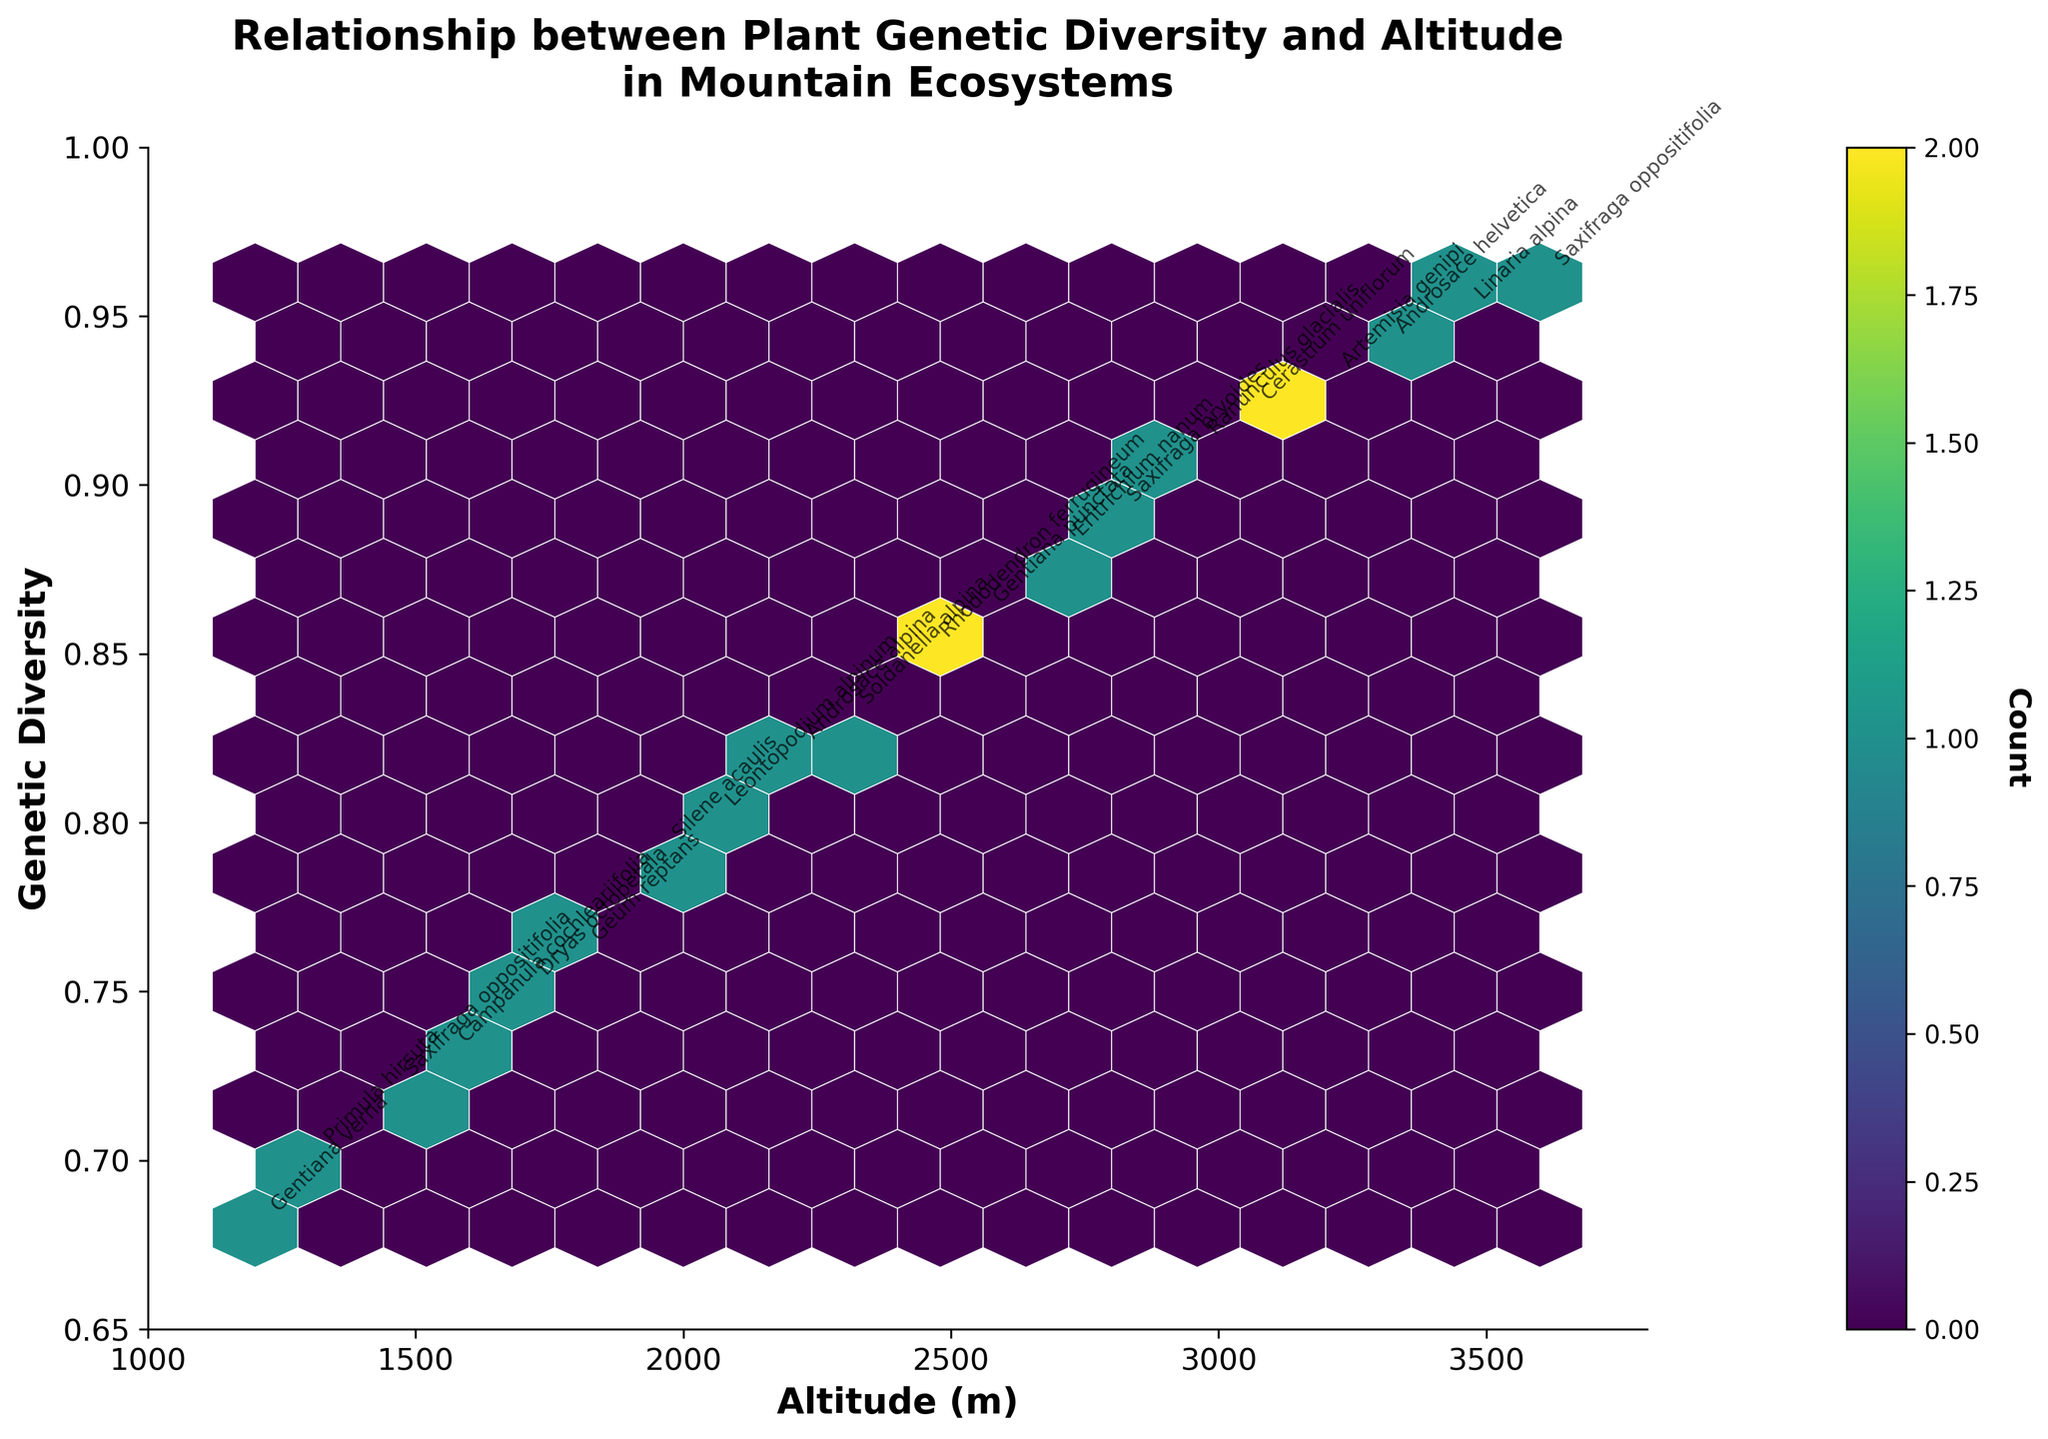What is the title of the plot? The title of the plot is shown at the top of the figure which reads "Relationship between Plant Genetic Diversity and Altitude in Mountain Ecosystems".
Answer: Relationship between Plant Genetic Diversity and Altitude in Mountain Ecosystems What are the x and y-axis labels? The x-axis label is "Altitude (m)", and the y-axis label is "Genetic Diversity". Both labels are clearly indicated along their respective axes.
Answer: Altitude (m), Genetic Diversity Which species has the highest altitude? By looking at the annotated data points, "Saxifraga oppositifolia" has the highest altitude of 3600 meters.
Answer: Saxifraga oppositifolia How many species have a genetic diversity greater than 0.90? From the annotations, the species "Ranunculus glacialis", "Artemisia genipi", "Linaria alpina", "Cerastium uniflorum", "Androsace helvetica", and "Saxifraga oppositifolia" have genetic diversity values greater than 0.90, so there are 6 species.
Answer: 6 What is the average genetic diversity of the species annotated with genome diversity details? The genetic diversity values for all species annotated are 0.68, 0.72, 0.75, 0.79, 0.82, 0.85, 0.88, 0.91, 0.93, 0.95, 0.70, 0.73, 0.76, 0.80, 0.83, 0.86, 0.89, 0.92, 0.94, 0.96. Adding these together gives 15.14 and dividing by 20 gives an average of 0.757.
Answer: 0.757 Which species has the lowest genetic diversity, and what is its altitude? The species annotated with the lowest genetic diversity is "Gentiana verna" with a genetic diversity of 0.68 at an altitude of 1200 meters.
Answer: Gentiana verna, 1200 meters Are there any species that appear twice on the plot? "Saxifraga oppositifolia" appears twice on the plot, at altitudes 1450 and 3600 meters.
Answer: Saxifraga oppositifolia Which altitude range shows the highest density of data points in the hexbin plot? Observing the color intensity in the hexbin plot, the highest density of data points appears between 1200 meters to 1450 meters. The darkest colored hexagons indicate this density range.
Answer: 1200-1450 meters Is there a clear trend visible between altitude and genetic diversity? By examining the annotations and hexagons, one can see that as altitude increases, genetic diversity also tends to increase.
Answer: Yes, increasing trend 